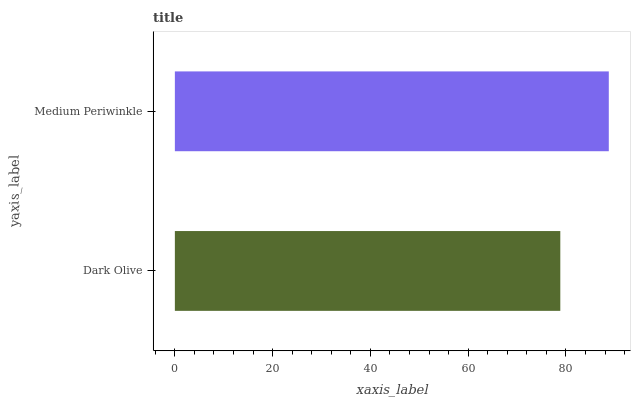Is Dark Olive the minimum?
Answer yes or no. Yes. Is Medium Periwinkle the maximum?
Answer yes or no. Yes. Is Medium Periwinkle the minimum?
Answer yes or no. No. Is Medium Periwinkle greater than Dark Olive?
Answer yes or no. Yes. Is Dark Olive less than Medium Periwinkle?
Answer yes or no. Yes. Is Dark Olive greater than Medium Periwinkle?
Answer yes or no. No. Is Medium Periwinkle less than Dark Olive?
Answer yes or no. No. Is Medium Periwinkle the high median?
Answer yes or no. Yes. Is Dark Olive the low median?
Answer yes or no. Yes. Is Dark Olive the high median?
Answer yes or no. No. Is Medium Periwinkle the low median?
Answer yes or no. No. 